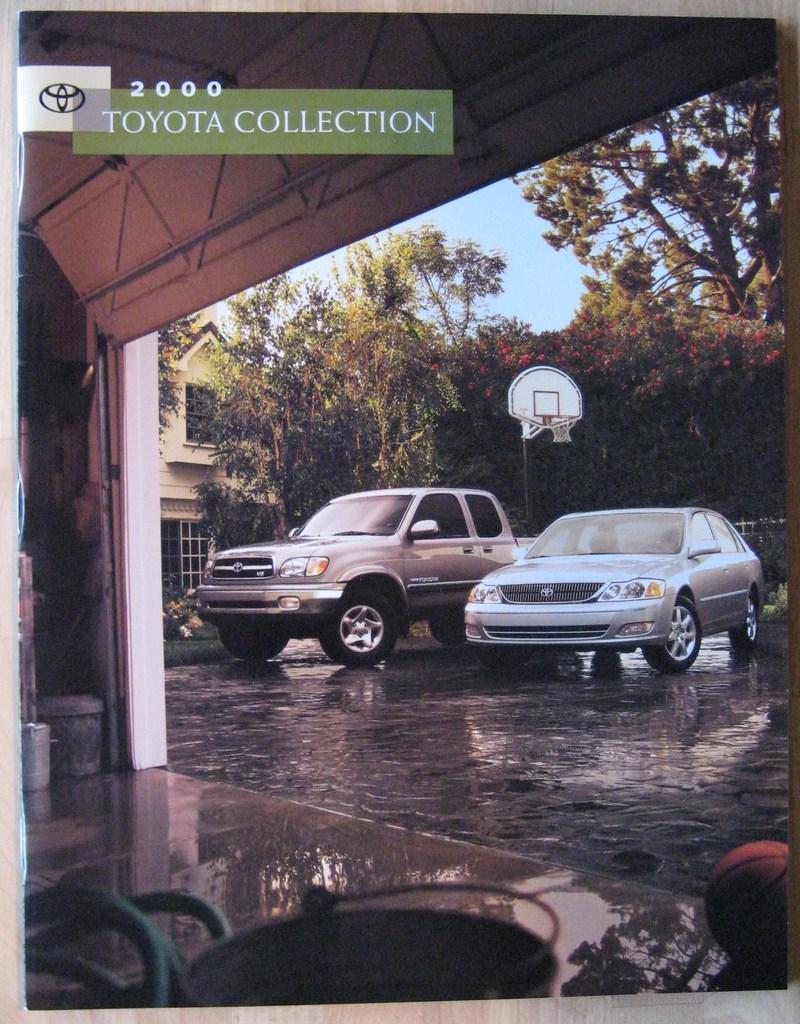In one or two sentences, can you explain what this image depicts? In the picture we can see outside the shed two cars are parked on the path and beside the cars we can see house and beside the house we can see trees and basket ball court and behind the trees we can see the part of the sky. 